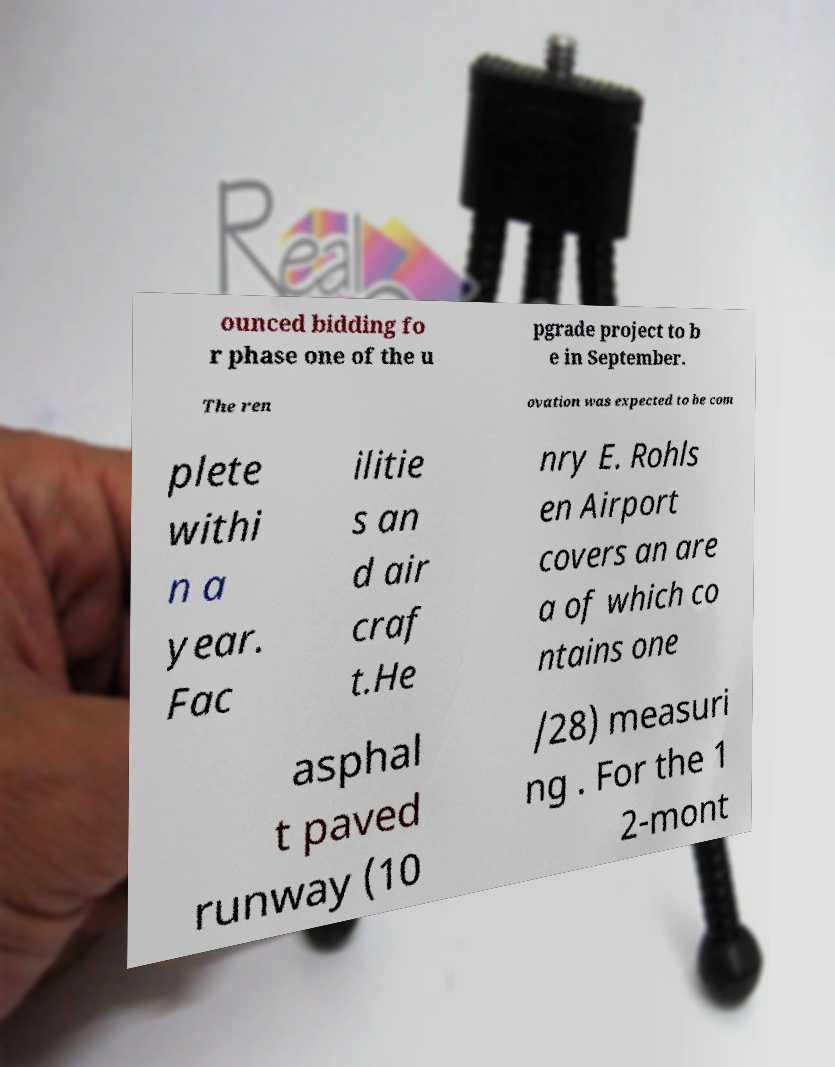For documentation purposes, I need the text within this image transcribed. Could you provide that? ounced bidding fo r phase one of the u pgrade project to b e in September. The ren ovation was expected to be com plete withi n a year. Fac ilitie s an d air craf t.He nry E. Rohls en Airport covers an are a of which co ntains one asphal t paved runway (10 /28) measuri ng . For the 1 2-mont 